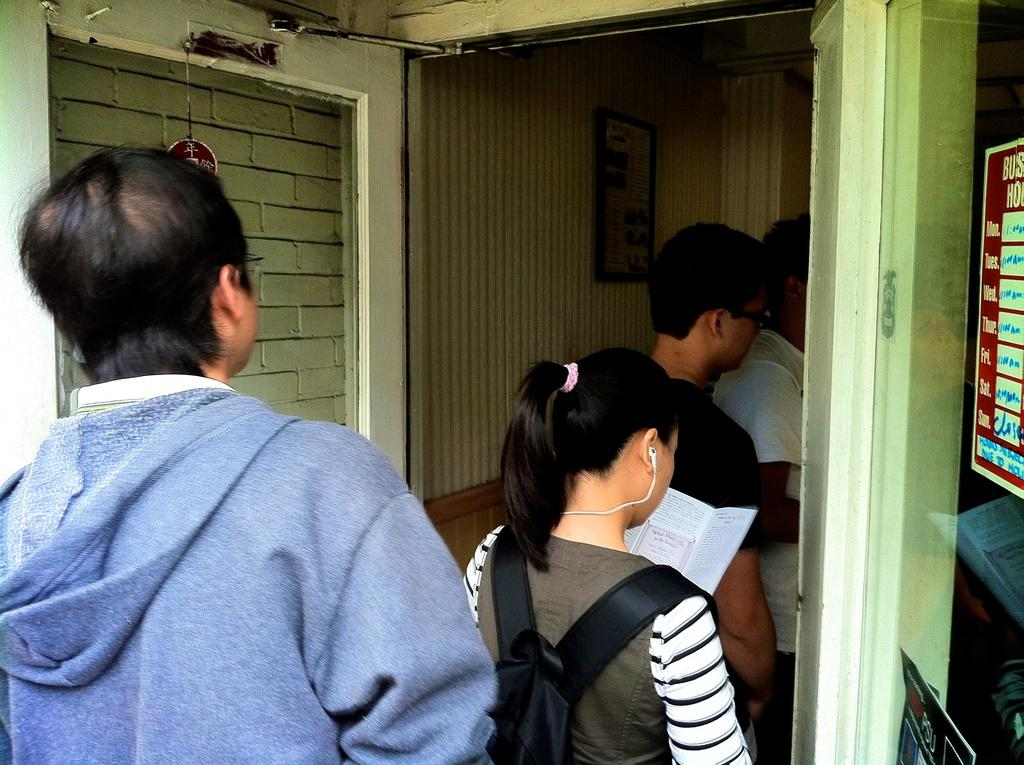What are the people in the image doing? The people in the image are standing in a queue. What can be seen in the background of the image? There is a wall in the image. Where is the paper located in the image? The paper is pasted on a glass window on the right side of the image. What type of control does the stomach have over the people in the image? The stomach does not have any control over the people in the image; it is not mentioned or depicted in the image. 